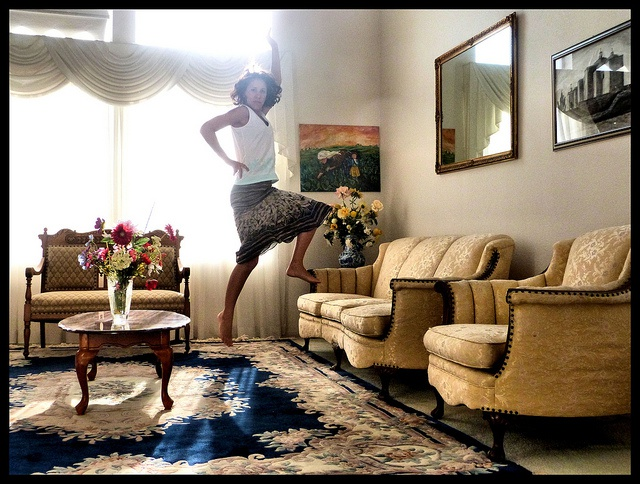Describe the objects in this image and their specific colors. I can see chair in black, maroon, and olive tones, couch in black, tan, and maroon tones, people in black, darkgray, gray, and lightgray tones, couch in black, maroon, and gray tones, and chair in black, maroon, and tan tones in this image. 